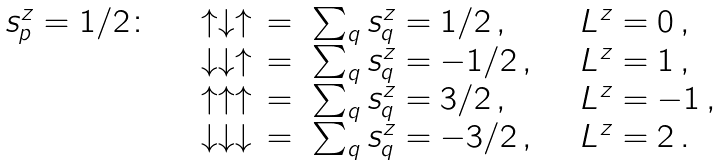Convert formula to latex. <formula><loc_0><loc_0><loc_500><loc_500>\begin{array} { l l l l } s ^ { z } _ { p } = 1 / 2 \colon \quad & \uparrow \downarrow \uparrow & = \ \sum _ { q } s _ { q } ^ { z } = 1 / 2 \, , & \quad L ^ { z } = 0 \, , \\ & \downarrow \downarrow \uparrow & = \ \sum _ { q } s _ { q } ^ { z } = - 1 / 2 \, , & \quad L ^ { z } = 1 \, , \\ & \uparrow \uparrow \uparrow & = \ \sum _ { q } s _ { q } ^ { z } = 3 / 2 \, , & \quad L ^ { z } = - 1 \, , \\ & \downarrow \downarrow \downarrow & = \ \sum _ { q } s _ { q } ^ { z } = - 3 / 2 \, , & \quad L ^ { z } = 2 \, . \end{array}</formula> 